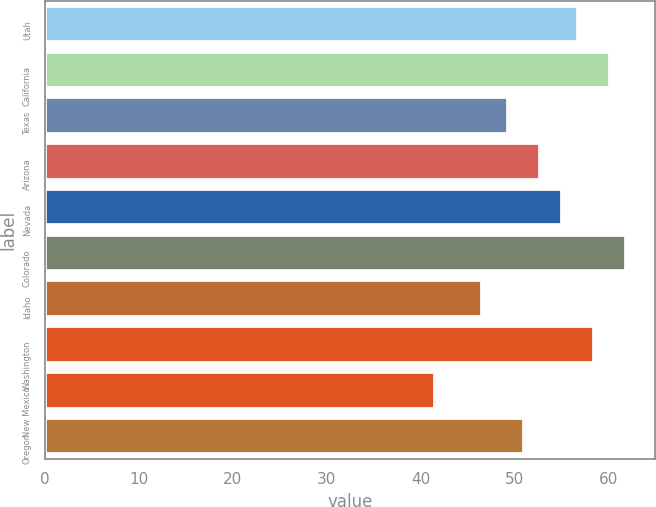<chart> <loc_0><loc_0><loc_500><loc_500><bar_chart><fcel>Utah<fcel>California<fcel>Texas<fcel>Arizona<fcel>Nevada<fcel>Colorado<fcel>Idaho<fcel>Washington<fcel>New Mexico<fcel>Oregon<nl><fcel>56.8<fcel>60.2<fcel>49.3<fcel>52.7<fcel>55.1<fcel>61.9<fcel>46.6<fcel>58.5<fcel>41.5<fcel>51<nl></chart> 